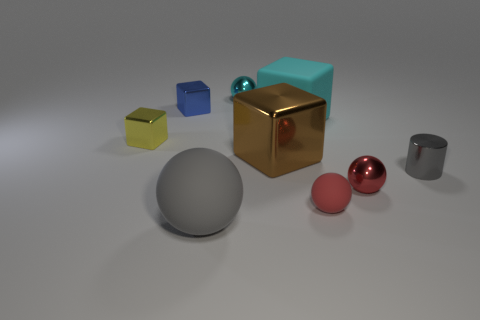Subtract all big cyan blocks. How many blocks are left? 3 Add 1 tiny blue shiny cylinders. How many objects exist? 10 Subtract 1 cylinders. How many cylinders are left? 0 Subtract all gray spheres. How many spheres are left? 3 Subtract all cylinders. How many objects are left? 8 Subtract all purple cubes. How many yellow cylinders are left? 0 Subtract all purple rubber things. Subtract all cyan matte cubes. How many objects are left? 8 Add 9 small cyan shiny objects. How many small cyan shiny objects are left? 10 Add 8 small metal cylinders. How many small metal cylinders exist? 9 Subtract 0 purple cylinders. How many objects are left? 9 